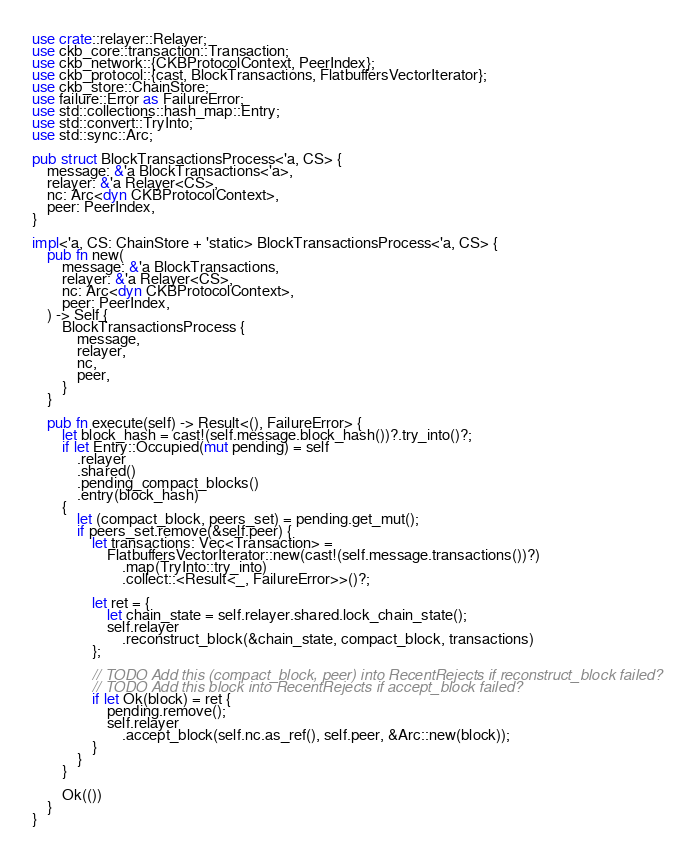Convert code to text. <code><loc_0><loc_0><loc_500><loc_500><_Rust_>use crate::relayer::Relayer;
use ckb_core::transaction::Transaction;
use ckb_network::{CKBProtocolContext, PeerIndex};
use ckb_protocol::{cast, BlockTransactions, FlatbuffersVectorIterator};
use ckb_store::ChainStore;
use failure::Error as FailureError;
use std::collections::hash_map::Entry;
use std::convert::TryInto;
use std::sync::Arc;

pub struct BlockTransactionsProcess<'a, CS> {
    message: &'a BlockTransactions<'a>,
    relayer: &'a Relayer<CS>,
    nc: Arc<dyn CKBProtocolContext>,
    peer: PeerIndex,
}

impl<'a, CS: ChainStore + 'static> BlockTransactionsProcess<'a, CS> {
    pub fn new(
        message: &'a BlockTransactions,
        relayer: &'a Relayer<CS>,
        nc: Arc<dyn CKBProtocolContext>,
        peer: PeerIndex,
    ) -> Self {
        BlockTransactionsProcess {
            message,
            relayer,
            nc,
            peer,
        }
    }

    pub fn execute(self) -> Result<(), FailureError> {
        let block_hash = cast!(self.message.block_hash())?.try_into()?;
        if let Entry::Occupied(mut pending) = self
            .relayer
            .shared()
            .pending_compact_blocks()
            .entry(block_hash)
        {
            let (compact_block, peers_set) = pending.get_mut();
            if peers_set.remove(&self.peer) {
                let transactions: Vec<Transaction> =
                    FlatbuffersVectorIterator::new(cast!(self.message.transactions())?)
                        .map(TryInto::try_into)
                        .collect::<Result<_, FailureError>>()?;

                let ret = {
                    let chain_state = self.relayer.shared.lock_chain_state();
                    self.relayer
                        .reconstruct_block(&chain_state, compact_block, transactions)
                };

                // TODO Add this (compact_block, peer) into RecentRejects if reconstruct_block failed?
                // TODO Add this block into RecentRejects if accept_block failed?
                if let Ok(block) = ret {
                    pending.remove();
                    self.relayer
                        .accept_block(self.nc.as_ref(), self.peer, &Arc::new(block));
                }
            }
        }

        Ok(())
    }
}
</code> 